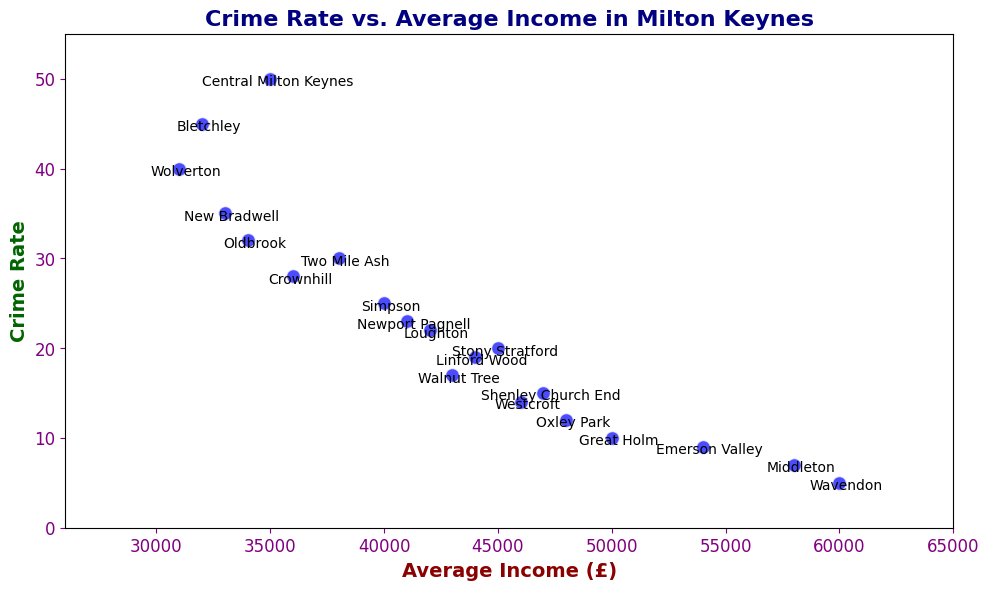What is the neighborhood with the highest crime rate? Identify the point on the scatter plot with the highest value on the y-axis (50) and read the corresponding neighborhood label.
Answer: Central Milton Keynes Which neighborhood has the highest average income, and what is its crime rate? Locate the point with the highest value on the x-axis (£60000) and read the corresponding neighborhood label and y-axis value.
Answer: Wavendon, 5 Are there more neighborhoods with an average income above £40000 or below £40000? Count the number of points to the right of and to the left of £40000 on the x-axis. There are 10 neighborhoods with an income above £40000 and 9 below £40000.
Answer: Above £40000 Which neighborhood has the lowest crime rate, and what is its average income? Identify the point on the scatter plot with the lowest value on the y-axis (5) and read the corresponding neighborhood label and x-axis value (£60000).
Answer: Wavendon, £60000 Do any neighborhoods have both a low crime rate (below 20) and a high average income (above £45000)? Locate points with y-values below 20 and x-values above £45000. Shenley Church End, Great Holm, Oxley Park, and Westcroft meet these criteria.
Answer: Shenley Church End, Great Holm, Oxley Park, Westcroft What is the combined average income of the neighborhoods with a crime rate greater than 30? Summing the x-values for neighborhoods with y-values greater than 30: £35000 (Central Milton Keynes) + £32000 (Bletchley) + £31000 (Wolverton) + £33000 (New Bradwell) + £34000 (Oldbrook) = £165000.
Answer: £165000 How does the crime rate in Simpson compare to that in Newport Pagnell? Find the y-values for both neighborhoods (Simpson: 25, Newport Pagnell: 23). Simpson has a crime rate of 25 while Newport Pagnell has 23.
Answer: Simpson is higher What is the average income of the neighborhood with a crime rate of 40? Locate the point with y-value of 40 and read the corresponding x-value (£31000).
Answer: £31000 Is there a clear trend between average income and crime rate? By examining the scatter plot, observe if there is an overall increase or decrease in one variable relative to the other. The trend appears to be inversely proportional: higher income levels generally correspond to lower crime rates.
Answer: Inversely proportional Which neighborhood with an average income above £45000 has the highest crime rate? Identify neighborhoods with x-values above £45000 and determine which has the highest y-value among them. Shenley Church End has an average income of £47000 and the highest crime rate of 15 among these neighborhoods.
Answer: Shenley Church End 